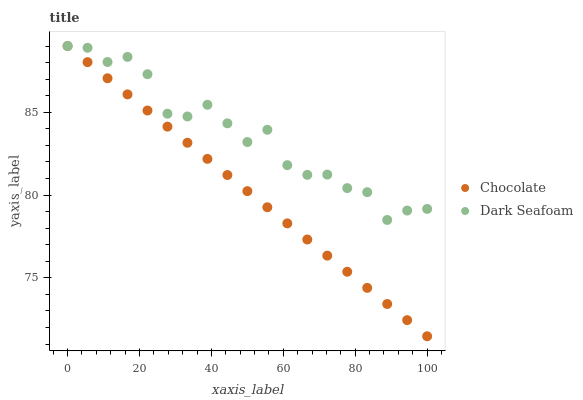Does Chocolate have the minimum area under the curve?
Answer yes or no. Yes. Does Dark Seafoam have the maximum area under the curve?
Answer yes or no. Yes. Does Chocolate have the maximum area under the curve?
Answer yes or no. No. Is Chocolate the smoothest?
Answer yes or no. Yes. Is Dark Seafoam the roughest?
Answer yes or no. Yes. Is Chocolate the roughest?
Answer yes or no. No. Does Chocolate have the lowest value?
Answer yes or no. Yes. Does Chocolate have the highest value?
Answer yes or no. Yes. Does Chocolate intersect Dark Seafoam?
Answer yes or no. Yes. Is Chocolate less than Dark Seafoam?
Answer yes or no. No. Is Chocolate greater than Dark Seafoam?
Answer yes or no. No. 